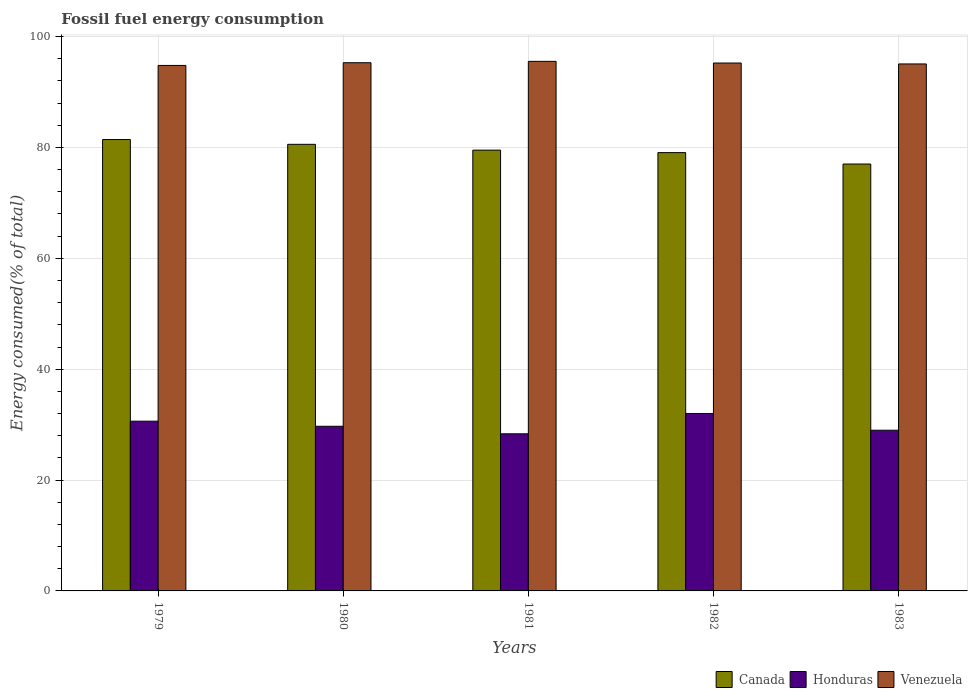How many different coloured bars are there?
Ensure brevity in your answer.  3. How many groups of bars are there?
Ensure brevity in your answer.  5. What is the label of the 2nd group of bars from the left?
Make the answer very short. 1980. In how many cases, is the number of bars for a given year not equal to the number of legend labels?
Offer a terse response. 0. What is the percentage of energy consumed in Venezuela in 1981?
Offer a very short reply. 95.53. Across all years, what is the maximum percentage of energy consumed in Venezuela?
Your answer should be very brief. 95.53. Across all years, what is the minimum percentage of energy consumed in Venezuela?
Ensure brevity in your answer.  94.79. In which year was the percentage of energy consumed in Canada maximum?
Give a very brief answer. 1979. What is the total percentage of energy consumed in Venezuela in the graph?
Make the answer very short. 475.9. What is the difference between the percentage of energy consumed in Venezuela in 1979 and that in 1980?
Give a very brief answer. -0.49. What is the difference between the percentage of energy consumed in Honduras in 1981 and the percentage of energy consumed in Canada in 1982?
Offer a terse response. -50.72. What is the average percentage of energy consumed in Venezuela per year?
Provide a succinct answer. 95.18. In the year 1979, what is the difference between the percentage of energy consumed in Honduras and percentage of energy consumed in Canada?
Make the answer very short. -50.81. What is the ratio of the percentage of energy consumed in Honduras in 1979 to that in 1981?
Ensure brevity in your answer.  1.08. Is the percentage of energy consumed in Canada in 1979 less than that in 1980?
Offer a very short reply. No. What is the difference between the highest and the second highest percentage of energy consumed in Canada?
Provide a short and direct response. 0.87. What is the difference between the highest and the lowest percentage of energy consumed in Venezuela?
Provide a short and direct response. 0.74. Is the sum of the percentage of energy consumed in Venezuela in 1979 and 1980 greater than the maximum percentage of energy consumed in Honduras across all years?
Make the answer very short. Yes. What does the 3rd bar from the right in 1980 represents?
Your response must be concise. Canada. Is it the case that in every year, the sum of the percentage of energy consumed in Venezuela and percentage of energy consumed in Honduras is greater than the percentage of energy consumed in Canada?
Ensure brevity in your answer.  Yes. Are all the bars in the graph horizontal?
Provide a succinct answer. No. Are the values on the major ticks of Y-axis written in scientific E-notation?
Your answer should be compact. No. Where does the legend appear in the graph?
Offer a very short reply. Bottom right. How many legend labels are there?
Make the answer very short. 3. How are the legend labels stacked?
Your answer should be very brief. Horizontal. What is the title of the graph?
Ensure brevity in your answer.  Fossil fuel energy consumption. Does "Other small states" appear as one of the legend labels in the graph?
Make the answer very short. No. What is the label or title of the X-axis?
Provide a short and direct response. Years. What is the label or title of the Y-axis?
Your answer should be compact. Energy consumed(% of total). What is the Energy consumed(% of total) in Canada in 1979?
Give a very brief answer. 81.43. What is the Energy consumed(% of total) of Honduras in 1979?
Your response must be concise. 30.62. What is the Energy consumed(% of total) in Venezuela in 1979?
Your answer should be compact. 94.79. What is the Energy consumed(% of total) in Canada in 1980?
Provide a short and direct response. 80.56. What is the Energy consumed(% of total) in Honduras in 1980?
Offer a very short reply. 29.7. What is the Energy consumed(% of total) of Venezuela in 1980?
Your answer should be very brief. 95.28. What is the Energy consumed(% of total) in Canada in 1981?
Your answer should be compact. 79.51. What is the Energy consumed(% of total) of Honduras in 1981?
Provide a succinct answer. 28.34. What is the Energy consumed(% of total) of Venezuela in 1981?
Ensure brevity in your answer.  95.53. What is the Energy consumed(% of total) in Canada in 1982?
Provide a short and direct response. 79.07. What is the Energy consumed(% of total) in Honduras in 1982?
Keep it short and to the point. 32.01. What is the Energy consumed(% of total) in Venezuela in 1982?
Offer a terse response. 95.23. What is the Energy consumed(% of total) in Canada in 1983?
Ensure brevity in your answer.  77.01. What is the Energy consumed(% of total) in Honduras in 1983?
Provide a short and direct response. 28.99. What is the Energy consumed(% of total) in Venezuela in 1983?
Your answer should be very brief. 95.06. Across all years, what is the maximum Energy consumed(% of total) of Canada?
Offer a terse response. 81.43. Across all years, what is the maximum Energy consumed(% of total) in Honduras?
Make the answer very short. 32.01. Across all years, what is the maximum Energy consumed(% of total) of Venezuela?
Ensure brevity in your answer.  95.53. Across all years, what is the minimum Energy consumed(% of total) in Canada?
Offer a very short reply. 77.01. Across all years, what is the minimum Energy consumed(% of total) of Honduras?
Keep it short and to the point. 28.34. Across all years, what is the minimum Energy consumed(% of total) of Venezuela?
Provide a short and direct response. 94.79. What is the total Energy consumed(% of total) of Canada in the graph?
Provide a short and direct response. 397.58. What is the total Energy consumed(% of total) in Honduras in the graph?
Give a very brief answer. 149.66. What is the total Energy consumed(% of total) of Venezuela in the graph?
Ensure brevity in your answer.  475.9. What is the difference between the Energy consumed(% of total) in Canada in 1979 and that in 1980?
Your answer should be compact. 0.87. What is the difference between the Energy consumed(% of total) in Honduras in 1979 and that in 1980?
Give a very brief answer. 0.92. What is the difference between the Energy consumed(% of total) in Venezuela in 1979 and that in 1980?
Your answer should be compact. -0.49. What is the difference between the Energy consumed(% of total) of Canada in 1979 and that in 1981?
Your response must be concise. 1.92. What is the difference between the Energy consumed(% of total) in Honduras in 1979 and that in 1981?
Provide a succinct answer. 2.28. What is the difference between the Energy consumed(% of total) in Venezuela in 1979 and that in 1981?
Make the answer very short. -0.74. What is the difference between the Energy consumed(% of total) in Canada in 1979 and that in 1982?
Your response must be concise. 2.36. What is the difference between the Energy consumed(% of total) of Honduras in 1979 and that in 1982?
Ensure brevity in your answer.  -1.39. What is the difference between the Energy consumed(% of total) in Venezuela in 1979 and that in 1982?
Ensure brevity in your answer.  -0.44. What is the difference between the Energy consumed(% of total) in Canada in 1979 and that in 1983?
Provide a short and direct response. 4.42. What is the difference between the Energy consumed(% of total) in Honduras in 1979 and that in 1983?
Your answer should be very brief. 1.63. What is the difference between the Energy consumed(% of total) in Venezuela in 1979 and that in 1983?
Make the answer very short. -0.27. What is the difference between the Energy consumed(% of total) in Canada in 1980 and that in 1981?
Offer a very short reply. 1.05. What is the difference between the Energy consumed(% of total) in Honduras in 1980 and that in 1981?
Offer a terse response. 1.36. What is the difference between the Energy consumed(% of total) of Venezuela in 1980 and that in 1981?
Your answer should be compact. -0.25. What is the difference between the Energy consumed(% of total) in Canada in 1980 and that in 1982?
Provide a short and direct response. 1.5. What is the difference between the Energy consumed(% of total) of Honduras in 1980 and that in 1982?
Offer a terse response. -2.31. What is the difference between the Energy consumed(% of total) in Venezuela in 1980 and that in 1982?
Keep it short and to the point. 0.05. What is the difference between the Energy consumed(% of total) in Canada in 1980 and that in 1983?
Offer a very short reply. 3.55. What is the difference between the Energy consumed(% of total) in Honduras in 1980 and that in 1983?
Offer a very short reply. 0.71. What is the difference between the Energy consumed(% of total) of Venezuela in 1980 and that in 1983?
Make the answer very short. 0.22. What is the difference between the Energy consumed(% of total) of Canada in 1981 and that in 1982?
Your answer should be very brief. 0.45. What is the difference between the Energy consumed(% of total) of Honduras in 1981 and that in 1982?
Keep it short and to the point. -3.67. What is the difference between the Energy consumed(% of total) of Venezuela in 1981 and that in 1982?
Your answer should be very brief. 0.3. What is the difference between the Energy consumed(% of total) in Canada in 1981 and that in 1983?
Your answer should be compact. 2.5. What is the difference between the Energy consumed(% of total) of Honduras in 1981 and that in 1983?
Ensure brevity in your answer.  -0.65. What is the difference between the Energy consumed(% of total) in Venezuela in 1981 and that in 1983?
Keep it short and to the point. 0.47. What is the difference between the Energy consumed(% of total) in Canada in 1982 and that in 1983?
Provide a succinct answer. 2.06. What is the difference between the Energy consumed(% of total) of Honduras in 1982 and that in 1983?
Your answer should be compact. 3.02. What is the difference between the Energy consumed(% of total) in Venezuela in 1982 and that in 1983?
Ensure brevity in your answer.  0.17. What is the difference between the Energy consumed(% of total) of Canada in 1979 and the Energy consumed(% of total) of Honduras in 1980?
Give a very brief answer. 51.73. What is the difference between the Energy consumed(% of total) in Canada in 1979 and the Energy consumed(% of total) in Venezuela in 1980?
Make the answer very short. -13.85. What is the difference between the Energy consumed(% of total) in Honduras in 1979 and the Energy consumed(% of total) in Venezuela in 1980?
Your answer should be very brief. -64.66. What is the difference between the Energy consumed(% of total) of Canada in 1979 and the Energy consumed(% of total) of Honduras in 1981?
Provide a succinct answer. 53.09. What is the difference between the Energy consumed(% of total) in Canada in 1979 and the Energy consumed(% of total) in Venezuela in 1981?
Keep it short and to the point. -14.1. What is the difference between the Energy consumed(% of total) in Honduras in 1979 and the Energy consumed(% of total) in Venezuela in 1981?
Provide a short and direct response. -64.91. What is the difference between the Energy consumed(% of total) in Canada in 1979 and the Energy consumed(% of total) in Honduras in 1982?
Keep it short and to the point. 49.42. What is the difference between the Energy consumed(% of total) in Canada in 1979 and the Energy consumed(% of total) in Venezuela in 1982?
Your response must be concise. -13.8. What is the difference between the Energy consumed(% of total) in Honduras in 1979 and the Energy consumed(% of total) in Venezuela in 1982?
Give a very brief answer. -64.61. What is the difference between the Energy consumed(% of total) of Canada in 1979 and the Energy consumed(% of total) of Honduras in 1983?
Ensure brevity in your answer.  52.44. What is the difference between the Energy consumed(% of total) in Canada in 1979 and the Energy consumed(% of total) in Venezuela in 1983?
Your response must be concise. -13.63. What is the difference between the Energy consumed(% of total) in Honduras in 1979 and the Energy consumed(% of total) in Venezuela in 1983?
Offer a terse response. -64.44. What is the difference between the Energy consumed(% of total) of Canada in 1980 and the Energy consumed(% of total) of Honduras in 1981?
Offer a terse response. 52.22. What is the difference between the Energy consumed(% of total) of Canada in 1980 and the Energy consumed(% of total) of Venezuela in 1981?
Ensure brevity in your answer.  -14.97. What is the difference between the Energy consumed(% of total) in Honduras in 1980 and the Energy consumed(% of total) in Venezuela in 1981?
Make the answer very short. -65.83. What is the difference between the Energy consumed(% of total) in Canada in 1980 and the Energy consumed(% of total) in Honduras in 1982?
Offer a very short reply. 48.55. What is the difference between the Energy consumed(% of total) of Canada in 1980 and the Energy consumed(% of total) of Venezuela in 1982?
Your answer should be compact. -14.66. What is the difference between the Energy consumed(% of total) of Honduras in 1980 and the Energy consumed(% of total) of Venezuela in 1982?
Provide a short and direct response. -65.53. What is the difference between the Energy consumed(% of total) of Canada in 1980 and the Energy consumed(% of total) of Honduras in 1983?
Your answer should be compact. 51.57. What is the difference between the Energy consumed(% of total) in Canada in 1980 and the Energy consumed(% of total) in Venezuela in 1983?
Provide a succinct answer. -14.5. What is the difference between the Energy consumed(% of total) of Honduras in 1980 and the Energy consumed(% of total) of Venezuela in 1983?
Your response must be concise. -65.36. What is the difference between the Energy consumed(% of total) in Canada in 1981 and the Energy consumed(% of total) in Honduras in 1982?
Provide a short and direct response. 47.5. What is the difference between the Energy consumed(% of total) in Canada in 1981 and the Energy consumed(% of total) in Venezuela in 1982?
Make the answer very short. -15.71. What is the difference between the Energy consumed(% of total) of Honduras in 1981 and the Energy consumed(% of total) of Venezuela in 1982?
Offer a very short reply. -66.89. What is the difference between the Energy consumed(% of total) of Canada in 1981 and the Energy consumed(% of total) of Honduras in 1983?
Your response must be concise. 50.52. What is the difference between the Energy consumed(% of total) of Canada in 1981 and the Energy consumed(% of total) of Venezuela in 1983?
Give a very brief answer. -15.55. What is the difference between the Energy consumed(% of total) in Honduras in 1981 and the Energy consumed(% of total) in Venezuela in 1983?
Your response must be concise. -66.72. What is the difference between the Energy consumed(% of total) of Canada in 1982 and the Energy consumed(% of total) of Honduras in 1983?
Ensure brevity in your answer.  50.08. What is the difference between the Energy consumed(% of total) in Canada in 1982 and the Energy consumed(% of total) in Venezuela in 1983?
Your answer should be compact. -16. What is the difference between the Energy consumed(% of total) of Honduras in 1982 and the Energy consumed(% of total) of Venezuela in 1983?
Your response must be concise. -63.05. What is the average Energy consumed(% of total) in Canada per year?
Your response must be concise. 79.52. What is the average Energy consumed(% of total) in Honduras per year?
Make the answer very short. 29.93. What is the average Energy consumed(% of total) of Venezuela per year?
Offer a very short reply. 95.18. In the year 1979, what is the difference between the Energy consumed(% of total) of Canada and Energy consumed(% of total) of Honduras?
Make the answer very short. 50.81. In the year 1979, what is the difference between the Energy consumed(% of total) of Canada and Energy consumed(% of total) of Venezuela?
Provide a succinct answer. -13.36. In the year 1979, what is the difference between the Energy consumed(% of total) in Honduras and Energy consumed(% of total) in Venezuela?
Make the answer very short. -64.17. In the year 1980, what is the difference between the Energy consumed(% of total) in Canada and Energy consumed(% of total) in Honduras?
Provide a succinct answer. 50.86. In the year 1980, what is the difference between the Energy consumed(% of total) in Canada and Energy consumed(% of total) in Venezuela?
Offer a very short reply. -14.72. In the year 1980, what is the difference between the Energy consumed(% of total) of Honduras and Energy consumed(% of total) of Venezuela?
Give a very brief answer. -65.58. In the year 1981, what is the difference between the Energy consumed(% of total) in Canada and Energy consumed(% of total) in Honduras?
Make the answer very short. 51.17. In the year 1981, what is the difference between the Energy consumed(% of total) of Canada and Energy consumed(% of total) of Venezuela?
Your response must be concise. -16.02. In the year 1981, what is the difference between the Energy consumed(% of total) of Honduras and Energy consumed(% of total) of Venezuela?
Give a very brief answer. -67.19. In the year 1982, what is the difference between the Energy consumed(% of total) in Canada and Energy consumed(% of total) in Honduras?
Make the answer very short. 47.06. In the year 1982, what is the difference between the Energy consumed(% of total) in Canada and Energy consumed(% of total) in Venezuela?
Offer a very short reply. -16.16. In the year 1982, what is the difference between the Energy consumed(% of total) in Honduras and Energy consumed(% of total) in Venezuela?
Your answer should be compact. -63.22. In the year 1983, what is the difference between the Energy consumed(% of total) in Canada and Energy consumed(% of total) in Honduras?
Provide a succinct answer. 48.02. In the year 1983, what is the difference between the Energy consumed(% of total) of Canada and Energy consumed(% of total) of Venezuela?
Provide a short and direct response. -18.05. In the year 1983, what is the difference between the Energy consumed(% of total) in Honduras and Energy consumed(% of total) in Venezuela?
Ensure brevity in your answer.  -66.07. What is the ratio of the Energy consumed(% of total) of Canada in 1979 to that in 1980?
Your answer should be very brief. 1.01. What is the ratio of the Energy consumed(% of total) of Honduras in 1979 to that in 1980?
Your answer should be compact. 1.03. What is the ratio of the Energy consumed(% of total) in Venezuela in 1979 to that in 1980?
Provide a short and direct response. 0.99. What is the ratio of the Energy consumed(% of total) of Canada in 1979 to that in 1981?
Your response must be concise. 1.02. What is the ratio of the Energy consumed(% of total) in Honduras in 1979 to that in 1981?
Offer a terse response. 1.08. What is the ratio of the Energy consumed(% of total) in Venezuela in 1979 to that in 1981?
Offer a terse response. 0.99. What is the ratio of the Energy consumed(% of total) in Canada in 1979 to that in 1982?
Provide a short and direct response. 1.03. What is the ratio of the Energy consumed(% of total) of Honduras in 1979 to that in 1982?
Your response must be concise. 0.96. What is the ratio of the Energy consumed(% of total) in Venezuela in 1979 to that in 1982?
Your answer should be compact. 1. What is the ratio of the Energy consumed(% of total) of Canada in 1979 to that in 1983?
Offer a terse response. 1.06. What is the ratio of the Energy consumed(% of total) of Honduras in 1979 to that in 1983?
Offer a very short reply. 1.06. What is the ratio of the Energy consumed(% of total) of Canada in 1980 to that in 1981?
Give a very brief answer. 1.01. What is the ratio of the Energy consumed(% of total) of Honduras in 1980 to that in 1981?
Provide a succinct answer. 1.05. What is the ratio of the Energy consumed(% of total) of Venezuela in 1980 to that in 1981?
Ensure brevity in your answer.  1. What is the ratio of the Energy consumed(% of total) of Canada in 1980 to that in 1982?
Ensure brevity in your answer.  1.02. What is the ratio of the Energy consumed(% of total) in Honduras in 1980 to that in 1982?
Keep it short and to the point. 0.93. What is the ratio of the Energy consumed(% of total) of Canada in 1980 to that in 1983?
Offer a terse response. 1.05. What is the ratio of the Energy consumed(% of total) in Honduras in 1980 to that in 1983?
Your response must be concise. 1.02. What is the ratio of the Energy consumed(% of total) of Honduras in 1981 to that in 1982?
Your answer should be very brief. 0.89. What is the ratio of the Energy consumed(% of total) in Venezuela in 1981 to that in 1982?
Your answer should be compact. 1. What is the ratio of the Energy consumed(% of total) of Canada in 1981 to that in 1983?
Keep it short and to the point. 1.03. What is the ratio of the Energy consumed(% of total) of Honduras in 1981 to that in 1983?
Ensure brevity in your answer.  0.98. What is the ratio of the Energy consumed(% of total) in Venezuela in 1981 to that in 1983?
Provide a short and direct response. 1. What is the ratio of the Energy consumed(% of total) in Canada in 1982 to that in 1983?
Your answer should be compact. 1.03. What is the ratio of the Energy consumed(% of total) in Honduras in 1982 to that in 1983?
Offer a terse response. 1.1. What is the difference between the highest and the second highest Energy consumed(% of total) of Canada?
Make the answer very short. 0.87. What is the difference between the highest and the second highest Energy consumed(% of total) in Honduras?
Your answer should be very brief. 1.39. What is the difference between the highest and the second highest Energy consumed(% of total) of Venezuela?
Provide a short and direct response. 0.25. What is the difference between the highest and the lowest Energy consumed(% of total) in Canada?
Your answer should be very brief. 4.42. What is the difference between the highest and the lowest Energy consumed(% of total) in Honduras?
Your answer should be compact. 3.67. What is the difference between the highest and the lowest Energy consumed(% of total) in Venezuela?
Ensure brevity in your answer.  0.74. 